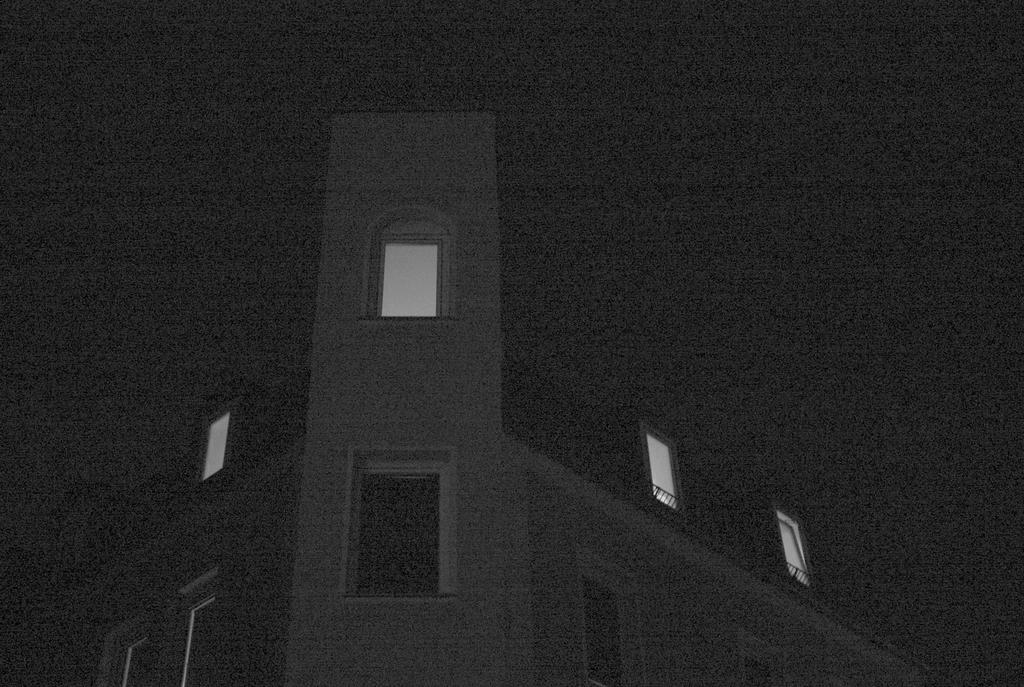What is the main structure in the image? There is a building in the image. What feature can be seen on the building? The building has windows. What type of question is being asked in the image? There is no question present in the image; it only features a building with windows. 